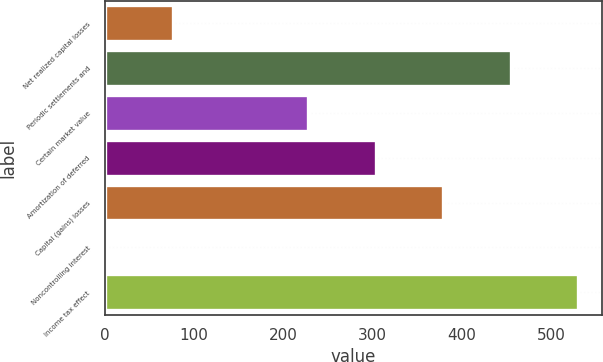Convert chart. <chart><loc_0><loc_0><loc_500><loc_500><bar_chart><fcel>Net realized capital losses<fcel>Periodic settlements and<fcel>Certain market value<fcel>Amortization of deferred<fcel>Capital (gains) losses<fcel>Noncontrolling interest<fcel>Income tax effect<nl><fcel>76.52<fcel>454.62<fcel>227.76<fcel>303.38<fcel>379<fcel>0.9<fcel>530.24<nl></chart> 